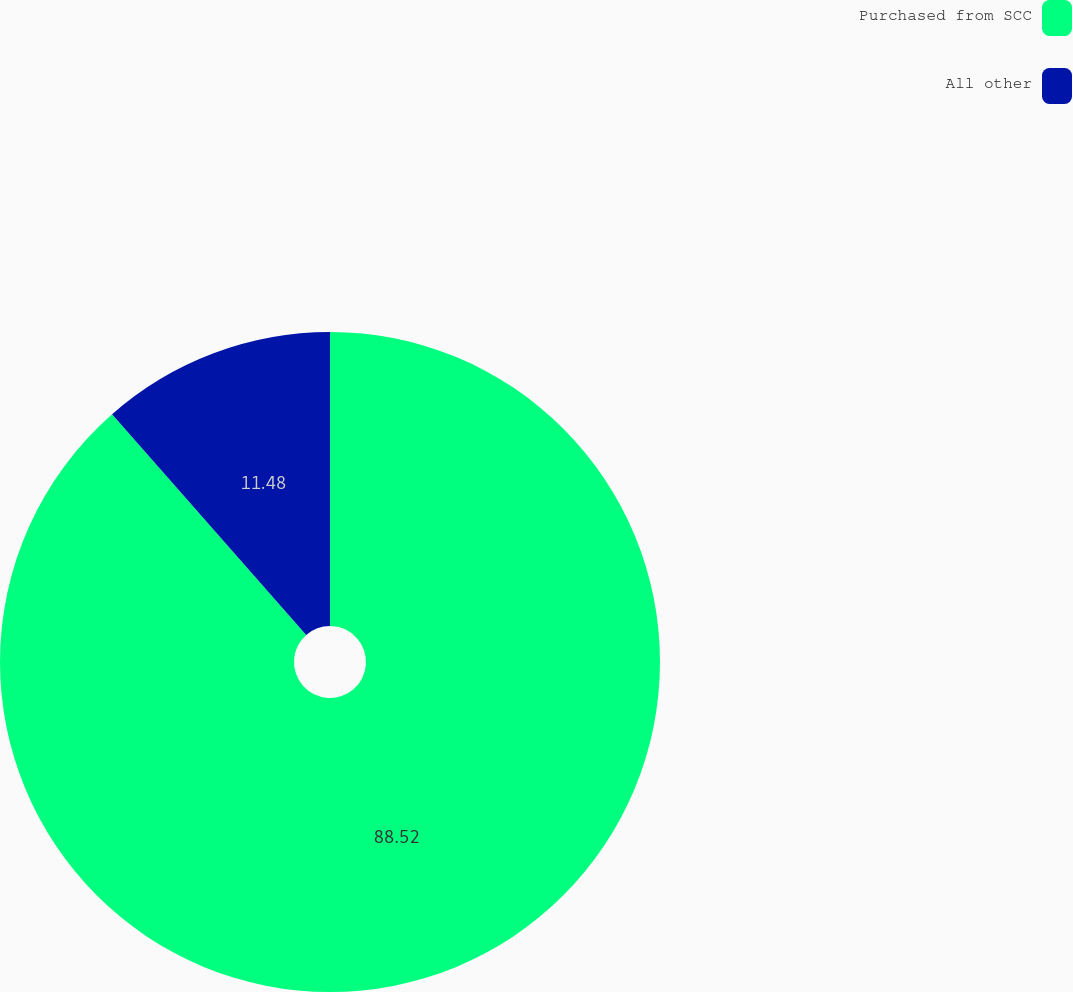Convert chart. <chart><loc_0><loc_0><loc_500><loc_500><pie_chart><fcel>Purchased from SCC<fcel>All other<nl><fcel>88.52%<fcel>11.48%<nl></chart> 